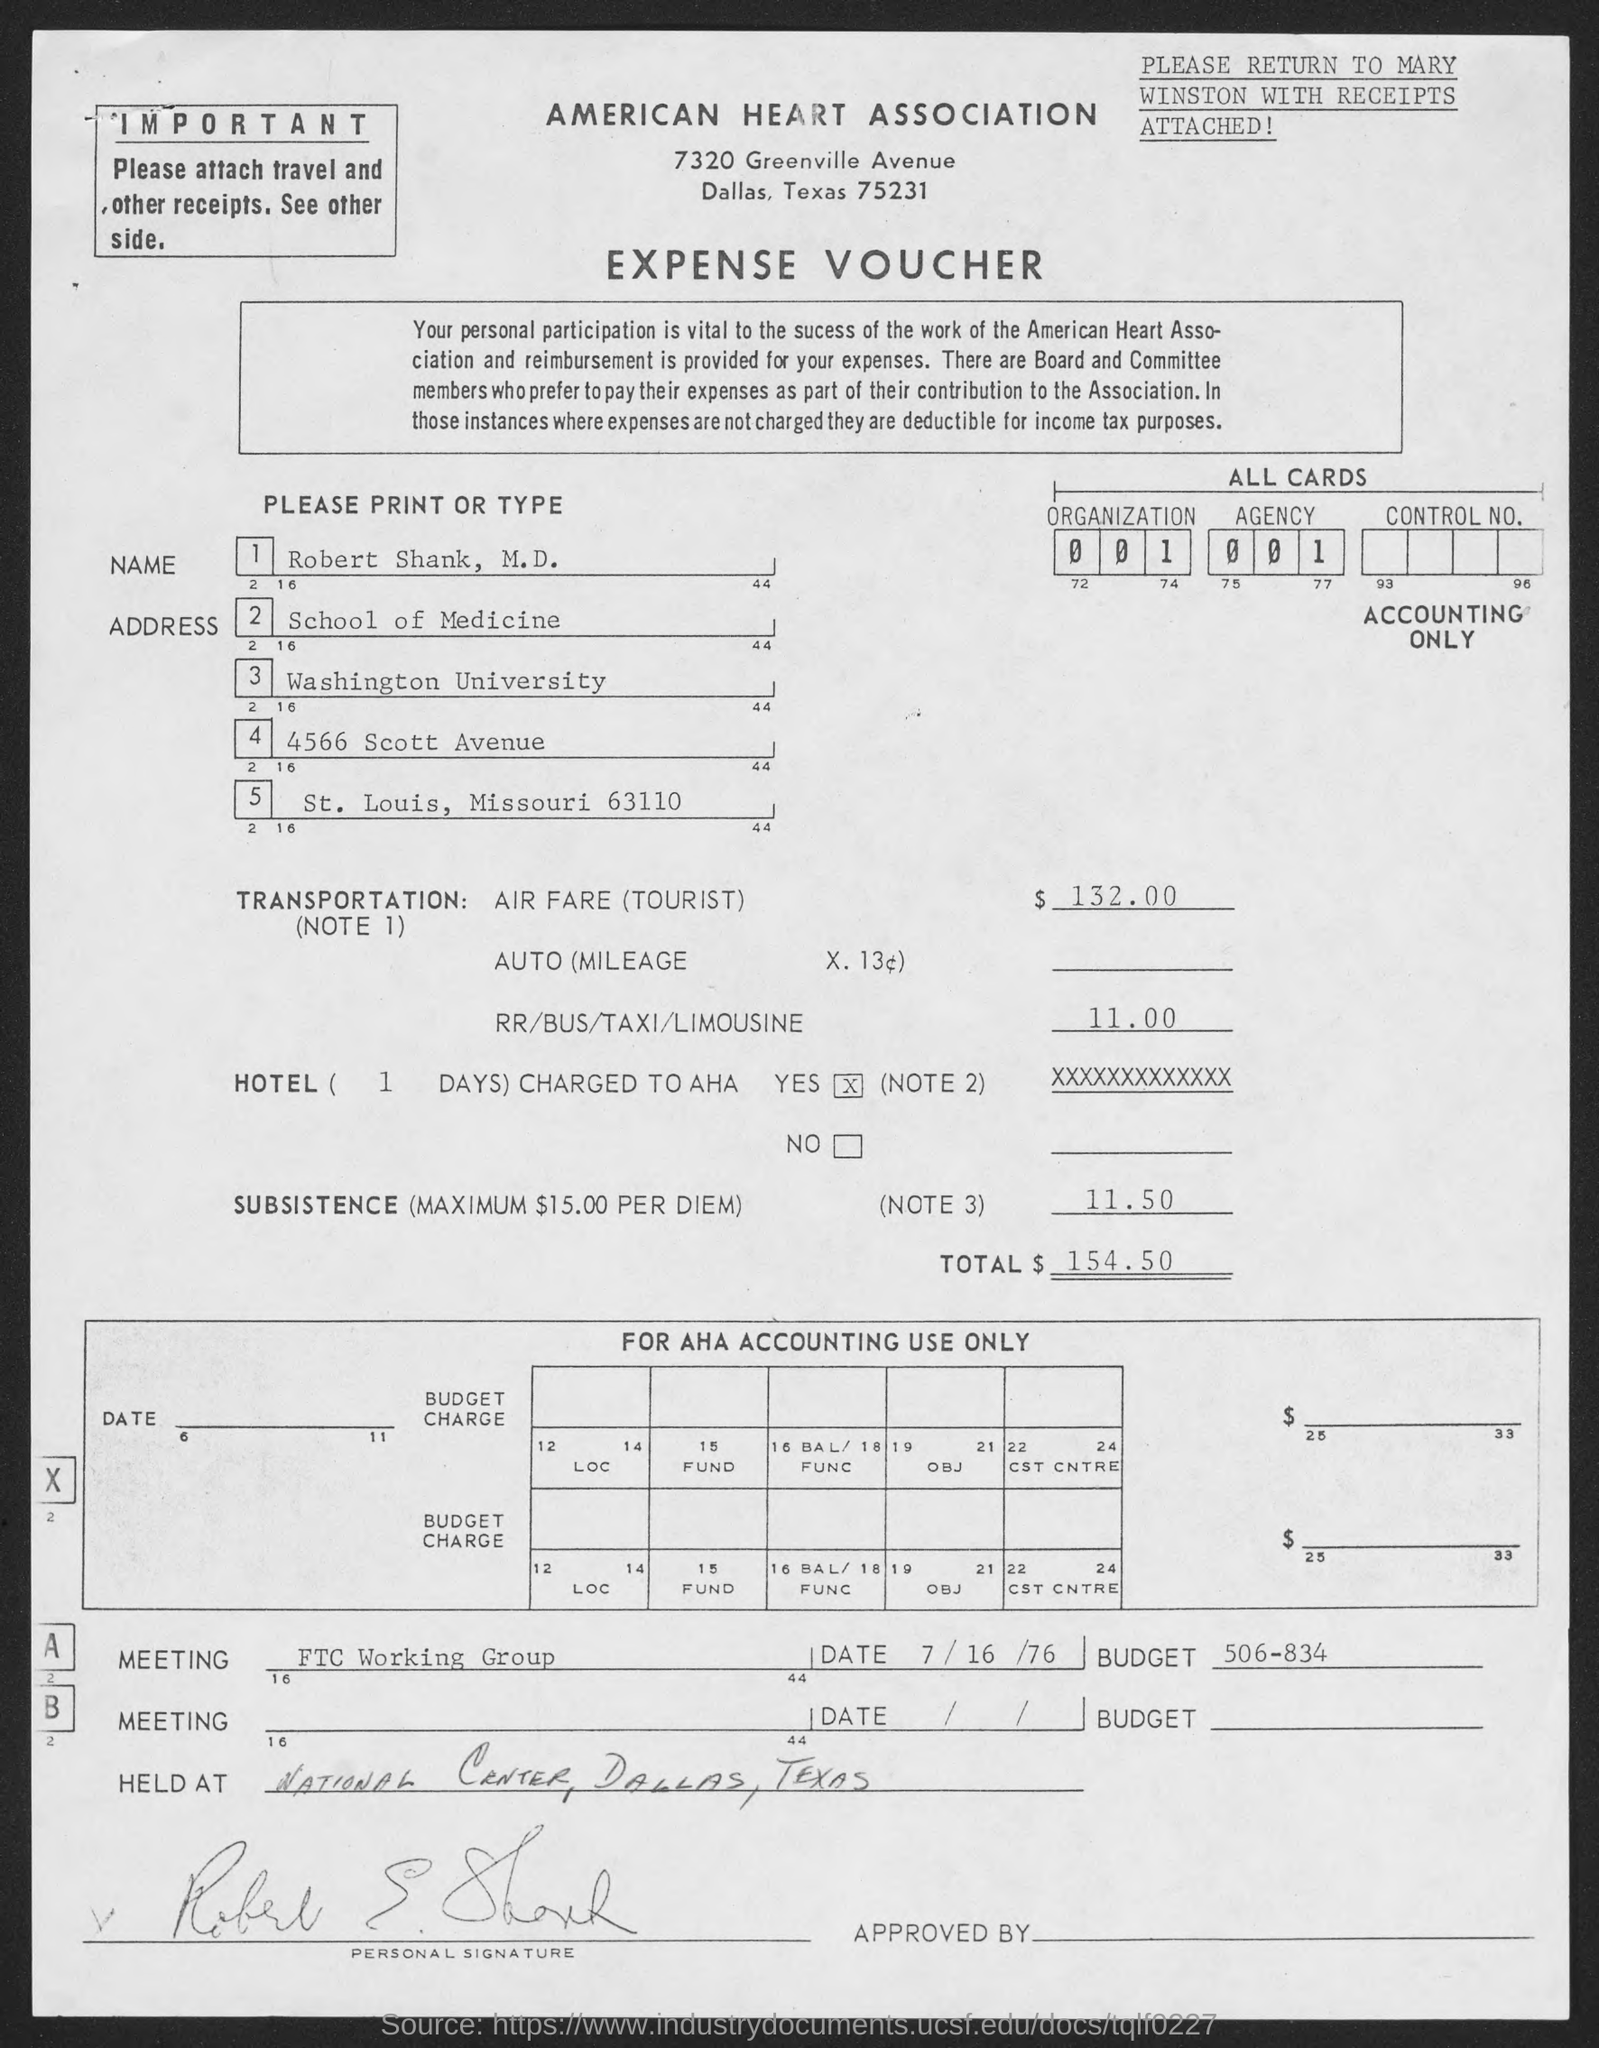Indicate a few pertinent items in this graphic. The total amount of expense is 154.50. Robert Shank, M.D. is a member of Washington University. The expense voucher lists the name "ROBERT SHANK, M.D.". 